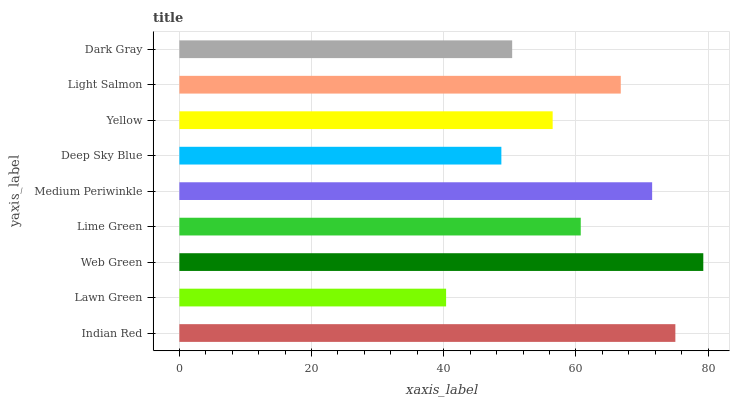Is Lawn Green the minimum?
Answer yes or no. Yes. Is Web Green the maximum?
Answer yes or no. Yes. Is Web Green the minimum?
Answer yes or no. No. Is Lawn Green the maximum?
Answer yes or no. No. Is Web Green greater than Lawn Green?
Answer yes or no. Yes. Is Lawn Green less than Web Green?
Answer yes or no. Yes. Is Lawn Green greater than Web Green?
Answer yes or no. No. Is Web Green less than Lawn Green?
Answer yes or no. No. Is Lime Green the high median?
Answer yes or no. Yes. Is Lime Green the low median?
Answer yes or no. Yes. Is Web Green the high median?
Answer yes or no. No. Is Medium Periwinkle the low median?
Answer yes or no. No. 